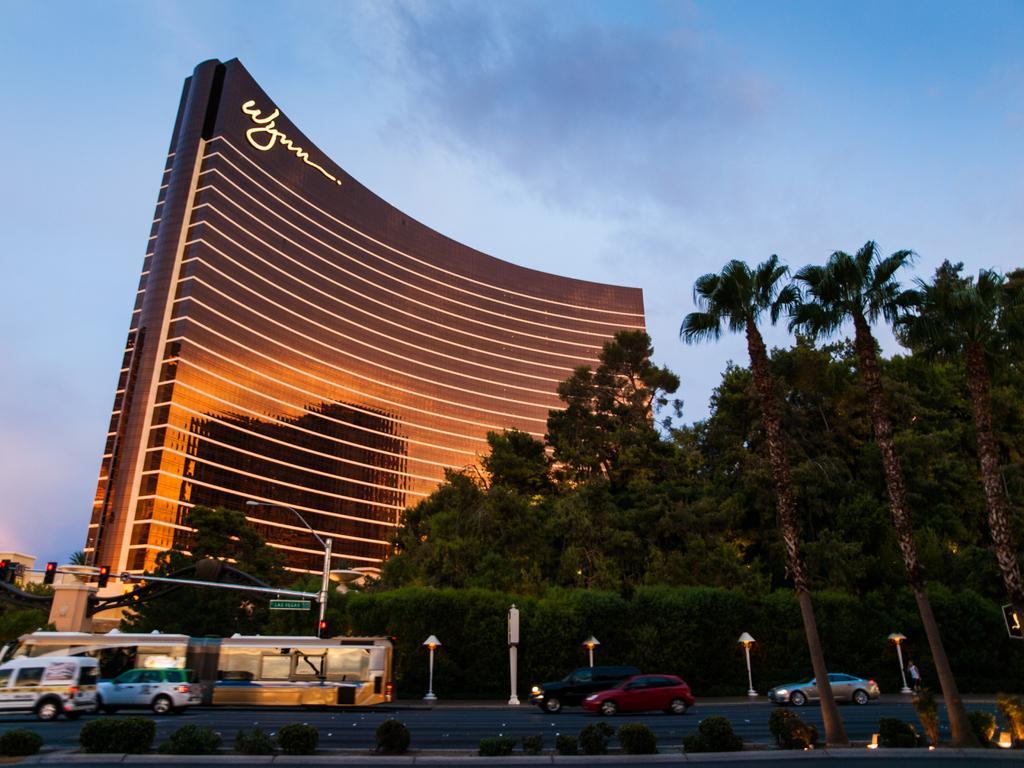Could you give a brief overview of what you see in this image? In this picture I can see the road in front, on which there are vehicles and I can see the plants, light poles, traffic signals and a person on the right bottom of this picture. In the background I can see the trees, a building on which there is something written and I can see the sky. 